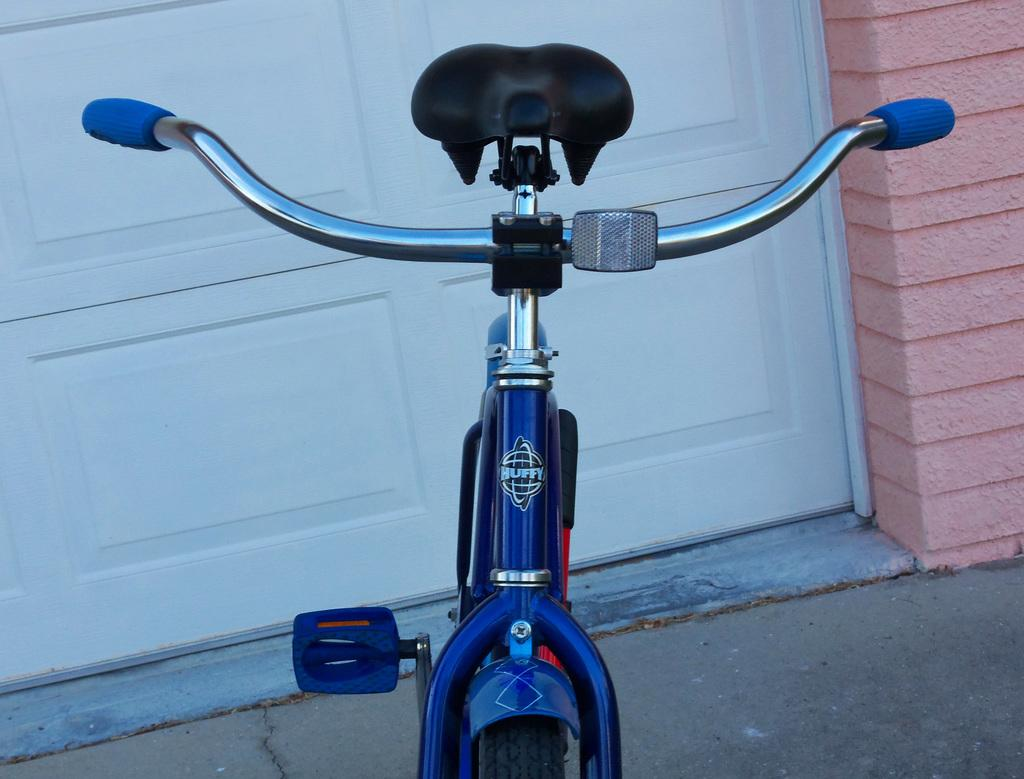What is the main object in the image? There is a cycle in the image. Where is the cycle located in relation to the door? The cycle is parked in front of a white door. What color is the wall on the right side of the image? There is a pink color wall on the right side of the image. How many rabbits are hopping around the cycle in the image? There are no rabbits present in the image. What type of whip is being used to control the cycle in the image? There is no whip present in the image, and cycles are not controlled by whips. 